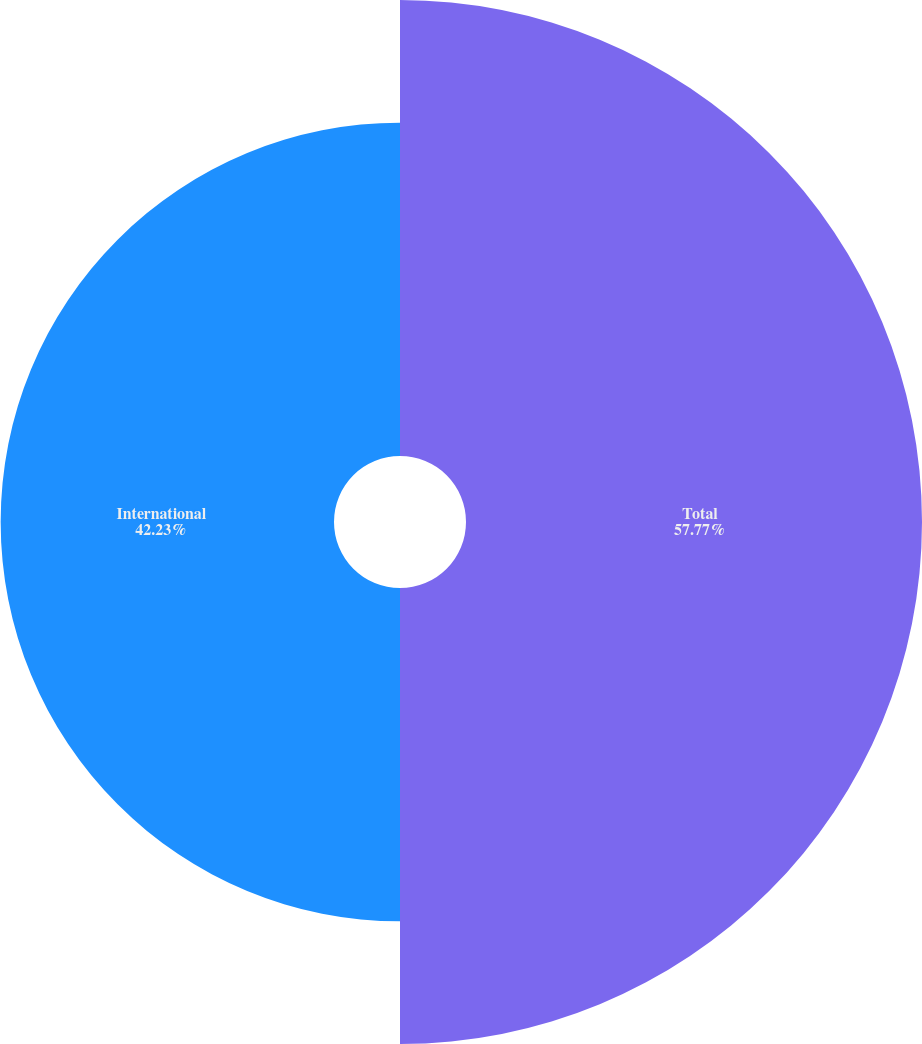Convert chart to OTSL. <chart><loc_0><loc_0><loc_500><loc_500><pie_chart><fcel>Total<fcel>International<nl><fcel>57.77%<fcel>42.23%<nl></chart> 